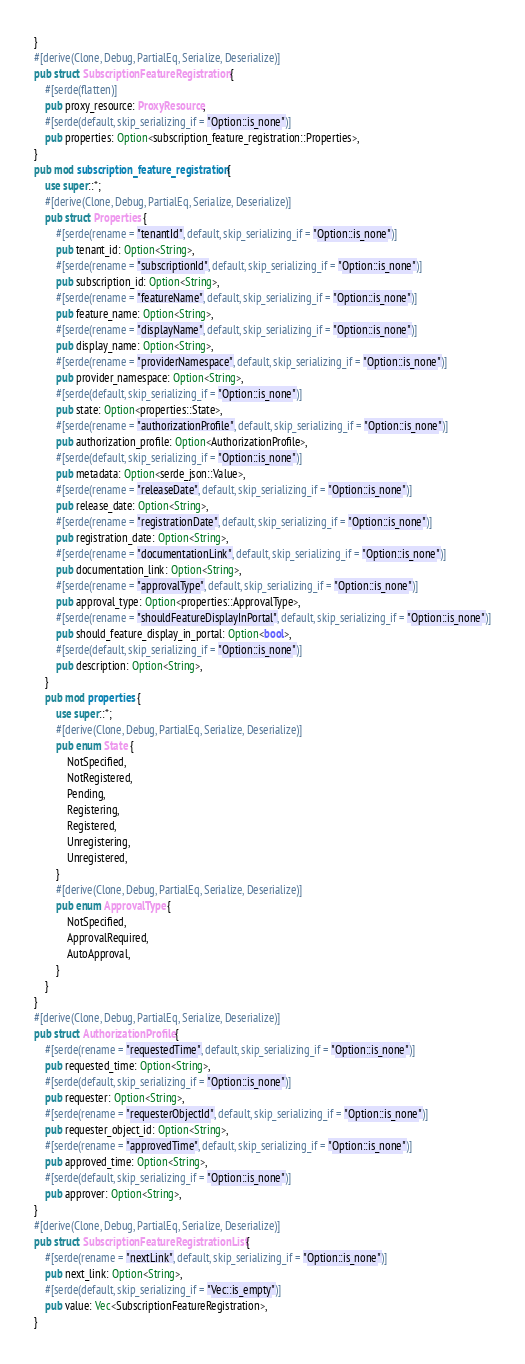<code> <loc_0><loc_0><loc_500><loc_500><_Rust_>}
#[derive(Clone, Debug, PartialEq, Serialize, Deserialize)]
pub struct SubscriptionFeatureRegistration {
    #[serde(flatten)]
    pub proxy_resource: ProxyResource,
    #[serde(default, skip_serializing_if = "Option::is_none")]
    pub properties: Option<subscription_feature_registration::Properties>,
}
pub mod subscription_feature_registration {
    use super::*;
    #[derive(Clone, Debug, PartialEq, Serialize, Deserialize)]
    pub struct Properties {
        #[serde(rename = "tenantId", default, skip_serializing_if = "Option::is_none")]
        pub tenant_id: Option<String>,
        #[serde(rename = "subscriptionId", default, skip_serializing_if = "Option::is_none")]
        pub subscription_id: Option<String>,
        #[serde(rename = "featureName", default, skip_serializing_if = "Option::is_none")]
        pub feature_name: Option<String>,
        #[serde(rename = "displayName", default, skip_serializing_if = "Option::is_none")]
        pub display_name: Option<String>,
        #[serde(rename = "providerNamespace", default, skip_serializing_if = "Option::is_none")]
        pub provider_namespace: Option<String>,
        #[serde(default, skip_serializing_if = "Option::is_none")]
        pub state: Option<properties::State>,
        #[serde(rename = "authorizationProfile", default, skip_serializing_if = "Option::is_none")]
        pub authorization_profile: Option<AuthorizationProfile>,
        #[serde(default, skip_serializing_if = "Option::is_none")]
        pub metadata: Option<serde_json::Value>,
        #[serde(rename = "releaseDate", default, skip_serializing_if = "Option::is_none")]
        pub release_date: Option<String>,
        #[serde(rename = "registrationDate", default, skip_serializing_if = "Option::is_none")]
        pub registration_date: Option<String>,
        #[serde(rename = "documentationLink", default, skip_serializing_if = "Option::is_none")]
        pub documentation_link: Option<String>,
        #[serde(rename = "approvalType", default, skip_serializing_if = "Option::is_none")]
        pub approval_type: Option<properties::ApprovalType>,
        #[serde(rename = "shouldFeatureDisplayInPortal", default, skip_serializing_if = "Option::is_none")]
        pub should_feature_display_in_portal: Option<bool>,
        #[serde(default, skip_serializing_if = "Option::is_none")]
        pub description: Option<String>,
    }
    pub mod properties {
        use super::*;
        #[derive(Clone, Debug, PartialEq, Serialize, Deserialize)]
        pub enum State {
            NotSpecified,
            NotRegistered,
            Pending,
            Registering,
            Registered,
            Unregistering,
            Unregistered,
        }
        #[derive(Clone, Debug, PartialEq, Serialize, Deserialize)]
        pub enum ApprovalType {
            NotSpecified,
            ApprovalRequired,
            AutoApproval,
        }
    }
}
#[derive(Clone, Debug, PartialEq, Serialize, Deserialize)]
pub struct AuthorizationProfile {
    #[serde(rename = "requestedTime", default, skip_serializing_if = "Option::is_none")]
    pub requested_time: Option<String>,
    #[serde(default, skip_serializing_if = "Option::is_none")]
    pub requester: Option<String>,
    #[serde(rename = "requesterObjectId", default, skip_serializing_if = "Option::is_none")]
    pub requester_object_id: Option<String>,
    #[serde(rename = "approvedTime", default, skip_serializing_if = "Option::is_none")]
    pub approved_time: Option<String>,
    #[serde(default, skip_serializing_if = "Option::is_none")]
    pub approver: Option<String>,
}
#[derive(Clone, Debug, PartialEq, Serialize, Deserialize)]
pub struct SubscriptionFeatureRegistrationList {
    #[serde(rename = "nextLink", default, skip_serializing_if = "Option::is_none")]
    pub next_link: Option<String>,
    #[serde(default, skip_serializing_if = "Vec::is_empty")]
    pub value: Vec<SubscriptionFeatureRegistration>,
}
</code> 